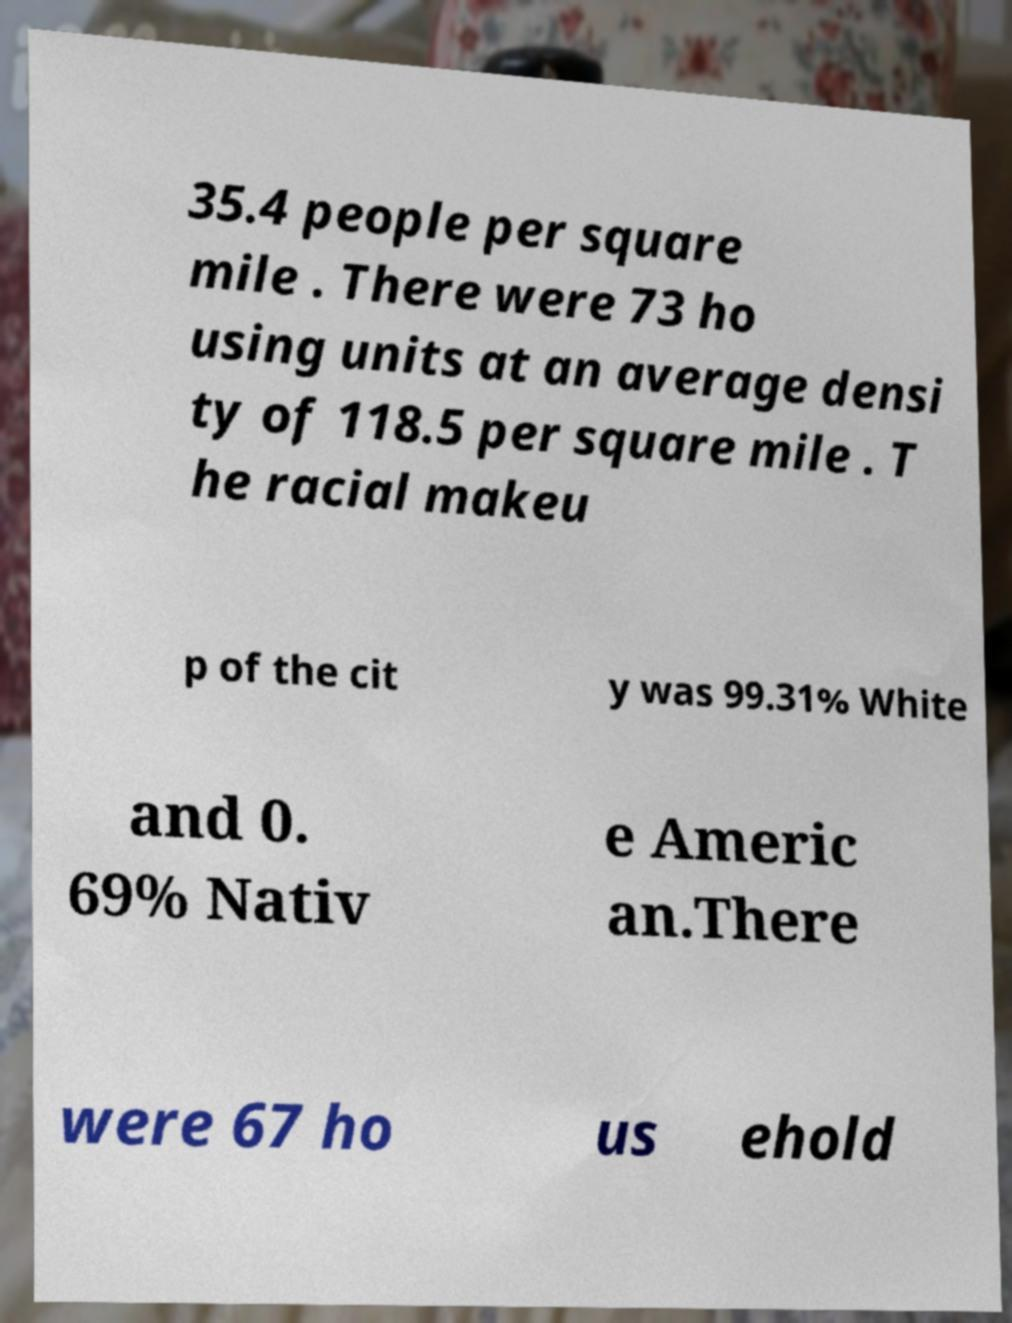There's text embedded in this image that I need extracted. Can you transcribe it verbatim? 35.4 people per square mile . There were 73 ho using units at an average densi ty of 118.5 per square mile . T he racial makeu p of the cit y was 99.31% White and 0. 69% Nativ e Americ an.There were 67 ho us ehold 